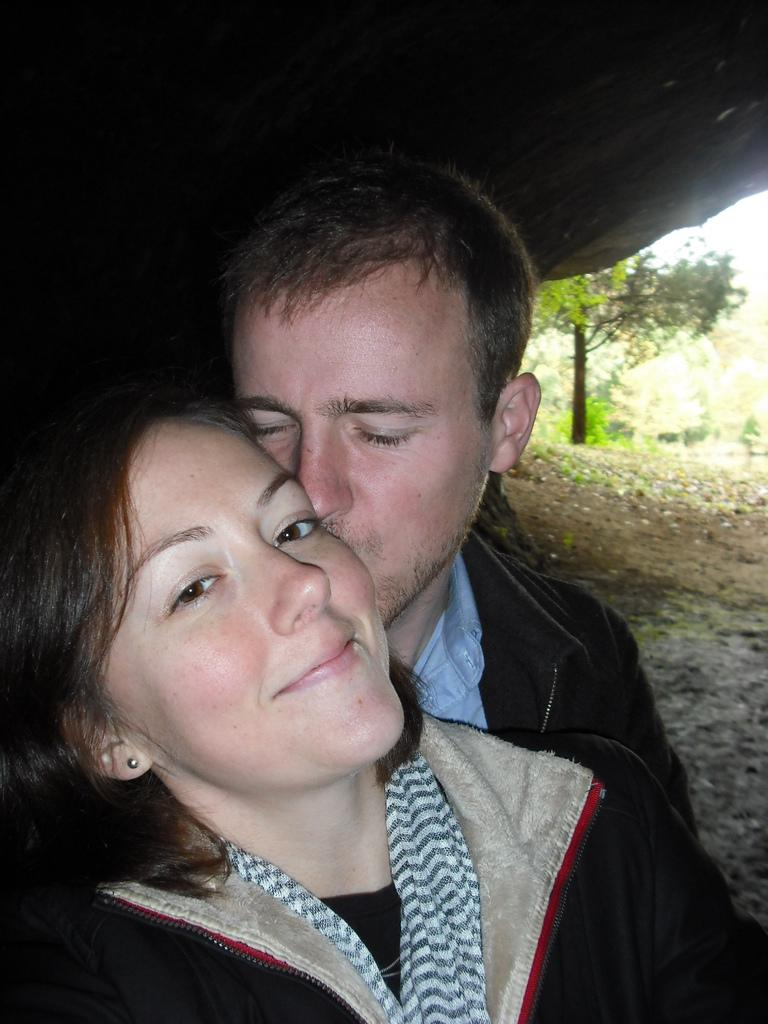What is happening between the man and the woman in the image? The man is kissing a woman in the image. How does the woman appear to feel about the interaction? The woman is smiling, which suggests she is happy or enjoying the interaction. What type of natural environment is visible in the background of the image? There are trees, grass, and soil in the background of the image, indicating a natural setting. What architectural feature can be seen in the background of the image? There is a path visible in the background of the image. What part of a building can be seen at the top of the image? There is a roof visible at the top of the image. What type of crime is being committed in the image? There is no crime being committed in the image; it shows a man kissing a woman. What level of education is required to understand the image? The image does not require any specific level of education to understand; it is a simple depiction of a man kissing a woman in a natural setting. 